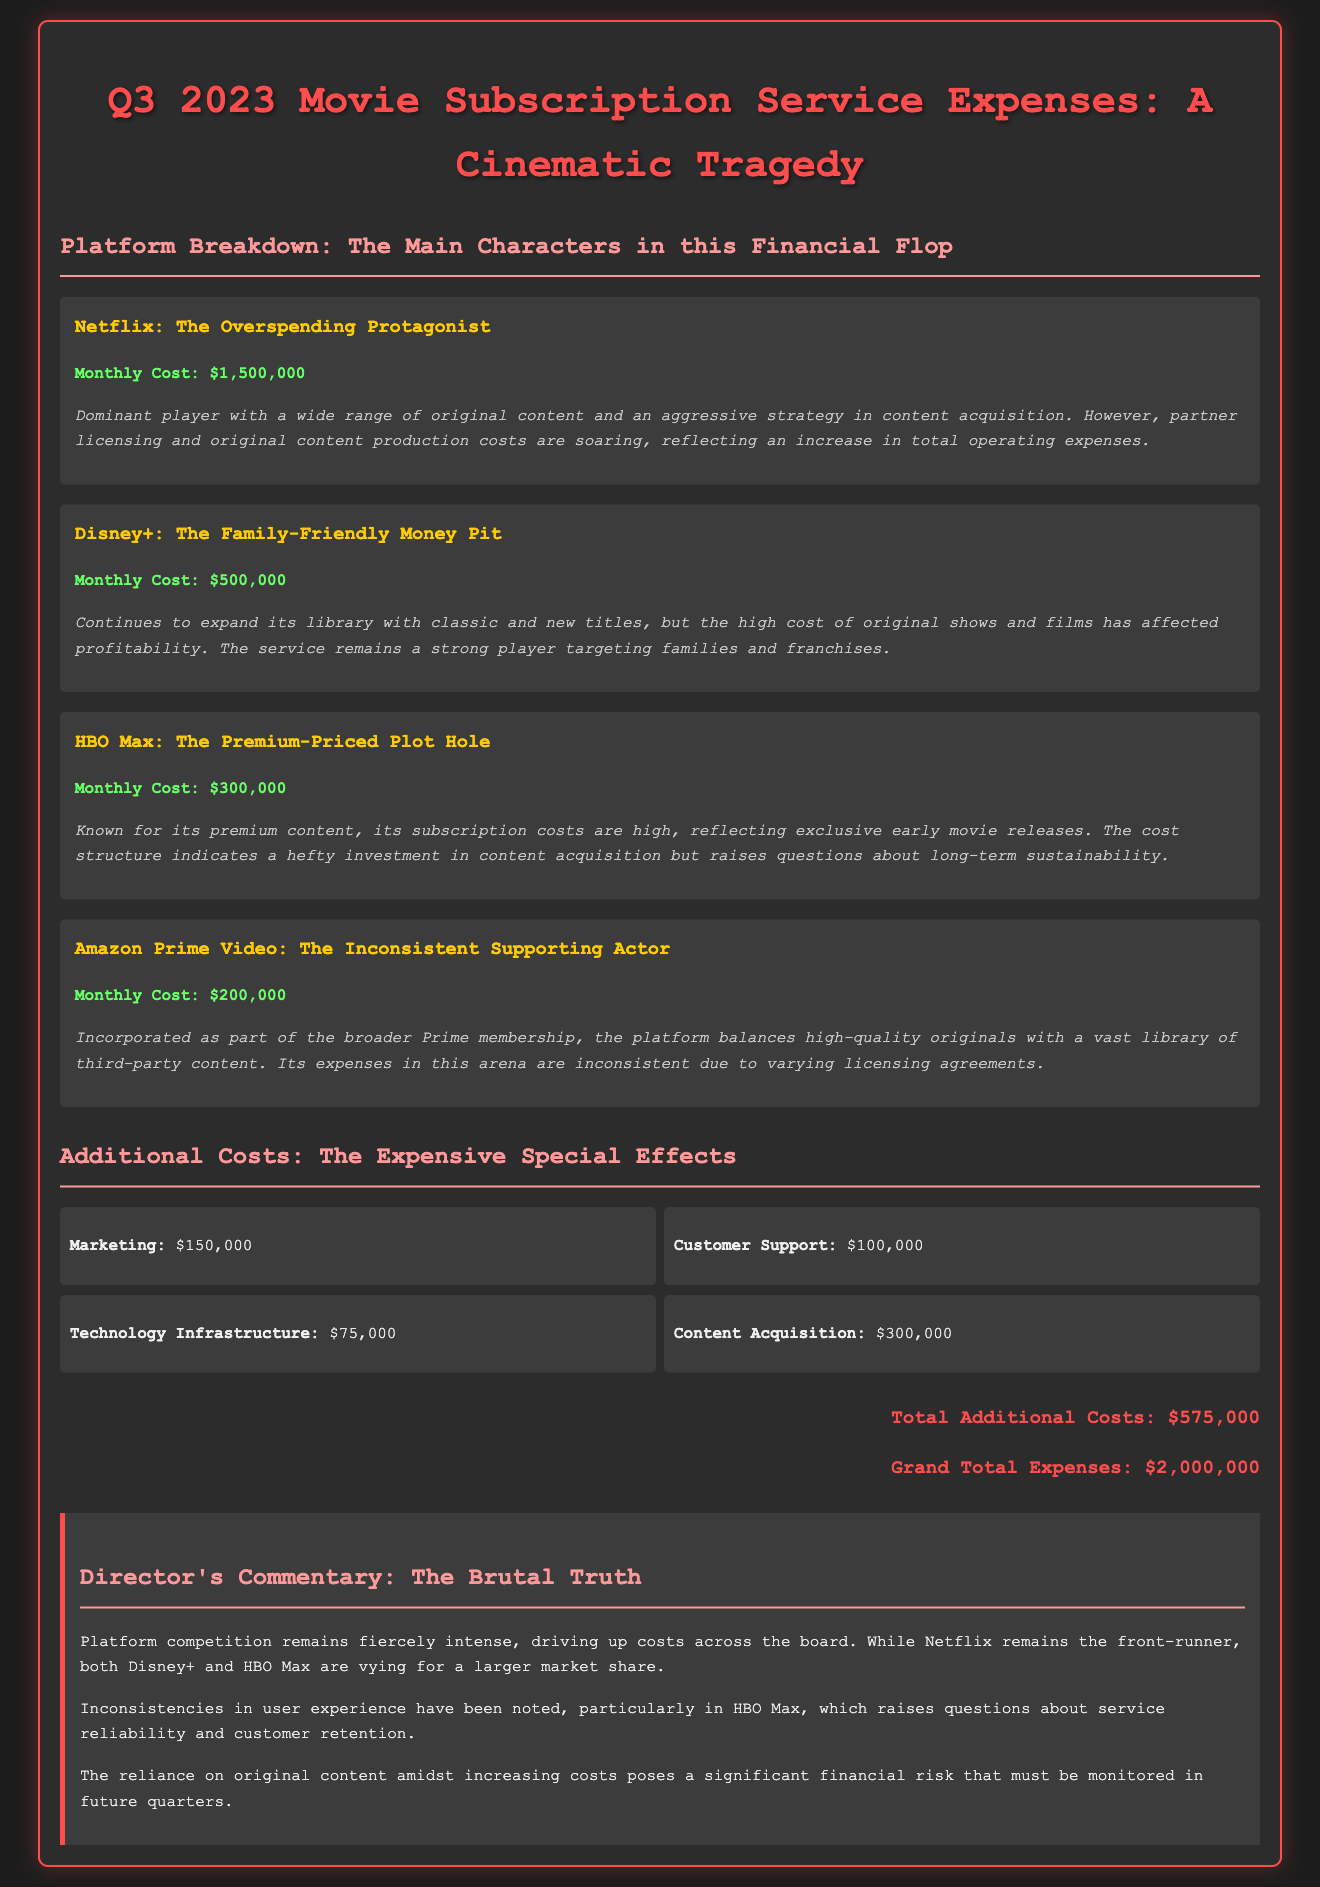What is the total monthly expense for Netflix? The total monthly expense for Netflix is directly stated in the document.
Answer: $1,500,000 What is the monthly cost for Disney+? The monthly cost for Disney+ is explicitly mentioned in the platform breakdown section.
Answer: $500,000 What additional cost category has the highest amount? Analyzing the additional costs, marketing stands out as the highest amount.
Answer: Marketing What is the total of all additional costs? The document provides a summary of the additional costs, allowing calculation.
Answer: $575,000 Which platform is described as the "Premium-Priced Plot Hole"? The description provided in the platform section explicitly labels HBO Max with this title.
Answer: HBO Max What is the grand total of expenses for Q3 2023? The grand total of expenses is noted at the end of the summary.
Answer: $2,000,000 What is one financial risk mentioned in the director's commentary? The commentary discusses financial risks associated with original content and increasing costs.
Answer: Original content costs Which platform has the lowest monthly cost? By comparing the monthly costs listed for each platform, Amazon Prime Video has the lowest.
Answer: $200,000 What specific item is mentioned under technology infrastructure costs? The document lists technology infrastructure as a cost, and its amount is specified.
Answer: $75,000 